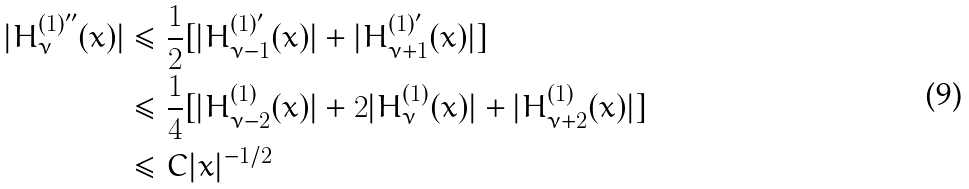Convert formula to latex. <formula><loc_0><loc_0><loc_500><loc_500>| H _ { \nu } ^ { ( 1 ) ^ { \prime \prime } } ( x ) | & \leq \frac { 1 } { 2 } [ | H _ { \nu - 1 } ^ { ( 1 ) ^ { \prime } } ( x ) | + | H _ { \nu + 1 } ^ { ( 1 ) ^ { \prime } } ( x ) | ] \\ & \leq \frac { 1 } { 4 } [ | H _ { \nu - 2 } ^ { ( 1 ) } ( x ) | + 2 | H _ { \nu } ^ { ( 1 ) } ( x ) | + | H _ { \nu + 2 } ^ { ( 1 ) } ( x ) | ] \\ & \leq C | x | ^ { - 1 / 2 }</formula> 